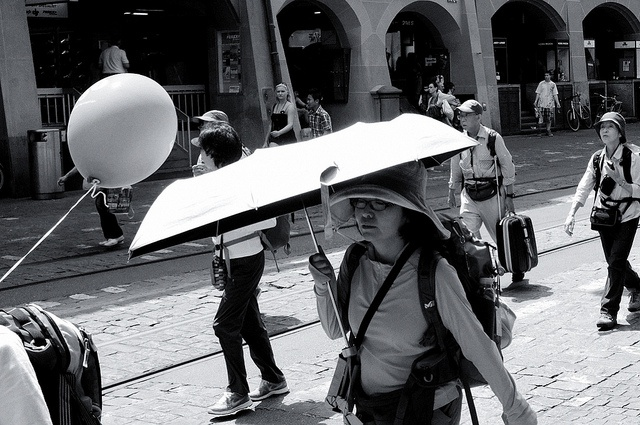Describe the objects in this image and their specific colors. I can see people in gray and black tones, umbrella in gray, white, black, and darkgray tones, people in gray, black, darkgray, and lightgray tones, people in gray, black, darkgray, and lightgray tones, and backpack in gray, black, lightgray, and darkgray tones in this image. 